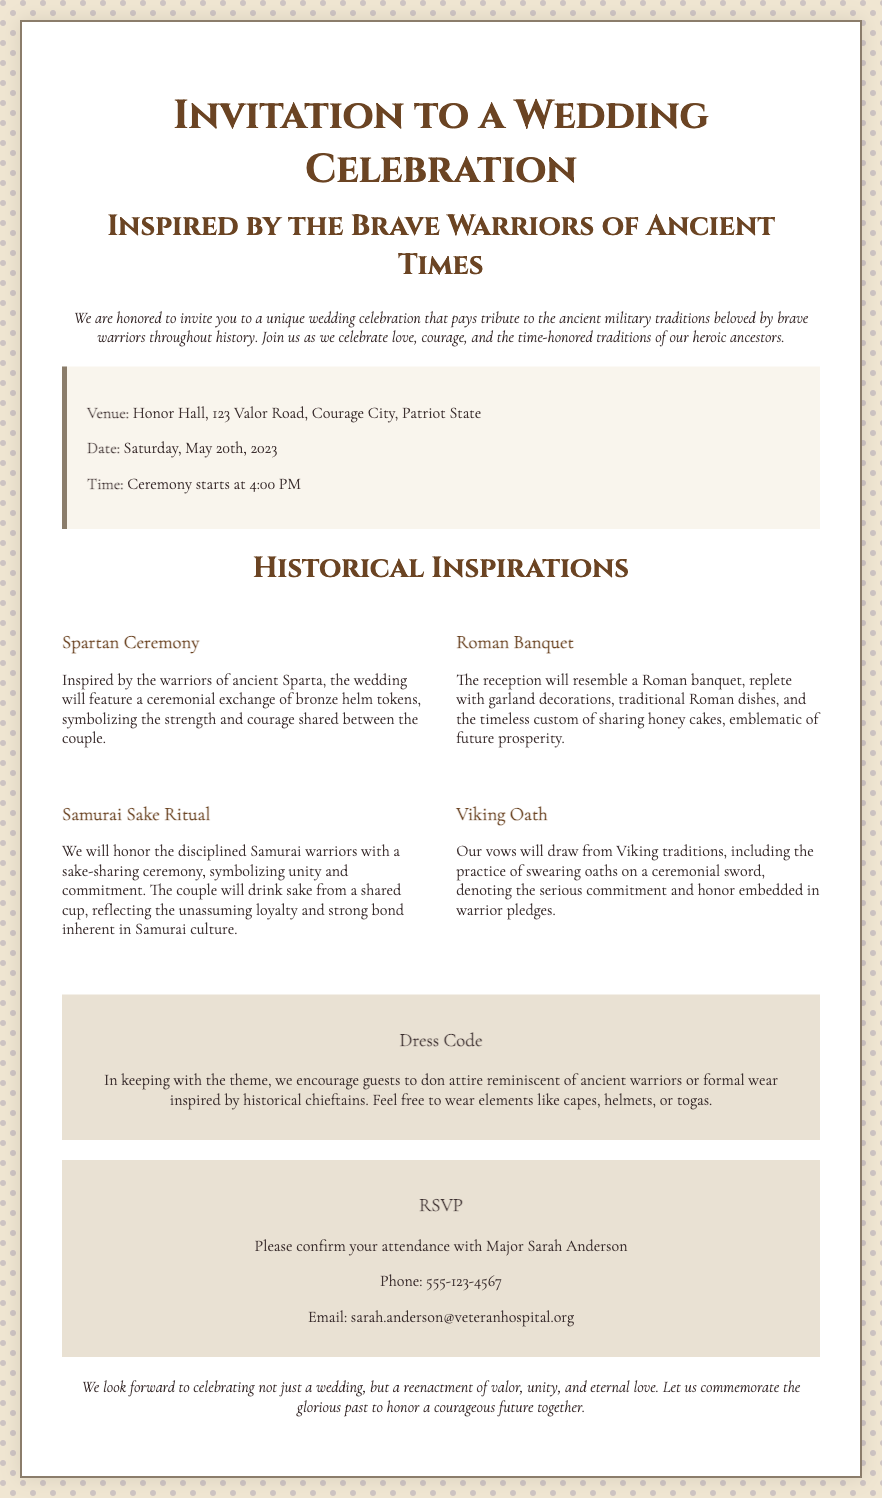What is the venue for the wedding? The venue is specified in the details section of the document, which states "Honor Hall, 123 Valor Road, Courage City, Patriot State."
Answer: Honor Hall, 123 Valor Road, Courage City, Patriot State What date is the wedding taking place? The wedding date is clearly mentioned in the details section of the invitation, which is "Saturday, May 20th, 2023."
Answer: Saturday, May 20th, 2023 What time does the ceremony start? The time of the ceremony is provided in the details section, stating that it "Ceremony starts at 4:00 PM."
Answer: 4:00 PM Which tradition involves a ceremonial sword? The Viking tradition is noted for involving a ceremonial sword during the vows.
Answer: Viking Oath What attire is encouraged for guests? The dress code section of the invitation encourages guests to wear attire reminiscent of ancient warriors or formal wear inspired by historical chieftains.
Answer: Ancient warriors or formal wear What is the purpose of the sake-sharing ceremony? The sake-sharing ceremony symbolizes "unity and commitment" among the couple.
Answer: Unity and commitment How can guests confirm their attendance? Guests are instructed to confirm their attendance with Major Sarah Anderson via phone or email.
Answer: Major Sarah Anderson What will the reception resemble? The reception is described as resembling a Roman banquet with decorations and traditional dishes.
Answer: Roman banquet 